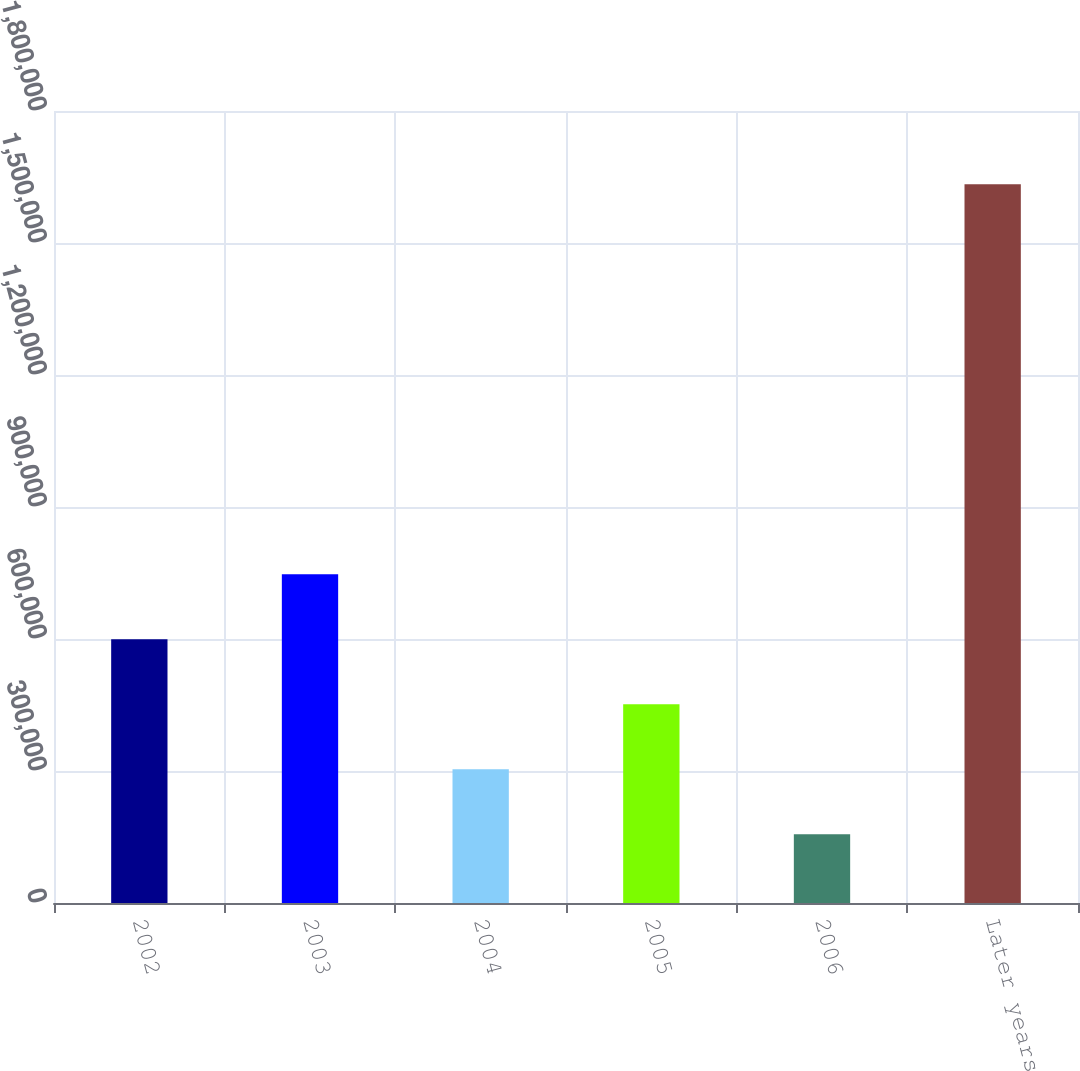Convert chart to OTSL. <chart><loc_0><loc_0><loc_500><loc_500><bar_chart><fcel>2002<fcel>2003<fcel>2004<fcel>2005<fcel>2006<fcel>Later years<nl><fcel>599371<fcel>747094<fcel>303925<fcel>451648<fcel>156202<fcel>1.63343e+06<nl></chart> 